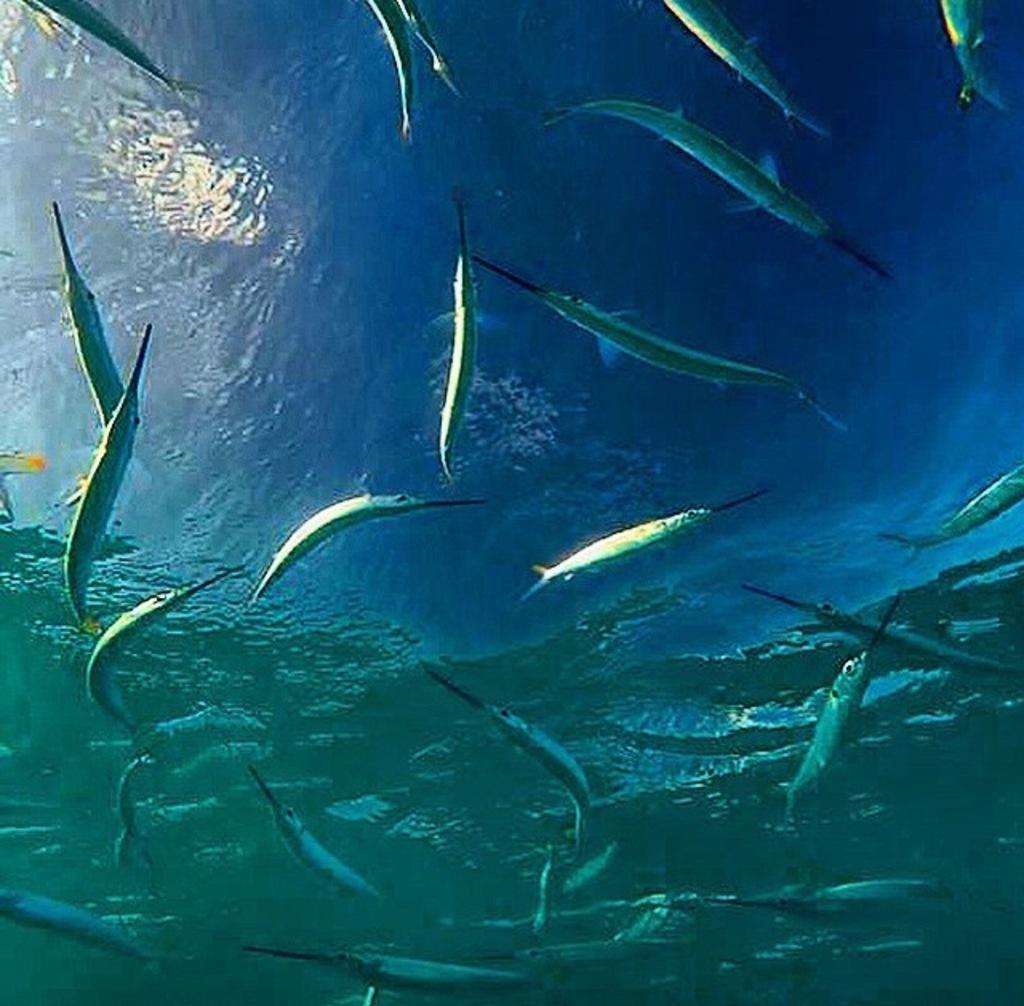Describe this image in one or two sentences. In this picture, we see the fishes are swimming in the water. This water might be in the sea or in the aquarium. 